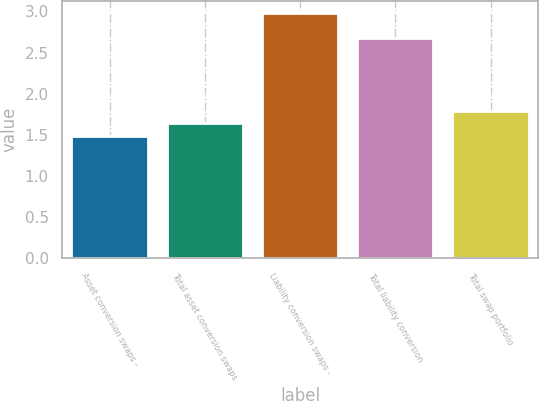Convert chart. <chart><loc_0><loc_0><loc_500><loc_500><bar_chart><fcel>Asset conversion swaps -<fcel>Total asset conversion swaps<fcel>Liability conversion swaps -<fcel>Total liability conversion<fcel>Total swap portfolio<nl><fcel>1.49<fcel>1.64<fcel>2.98<fcel>2.68<fcel>1.79<nl></chart> 